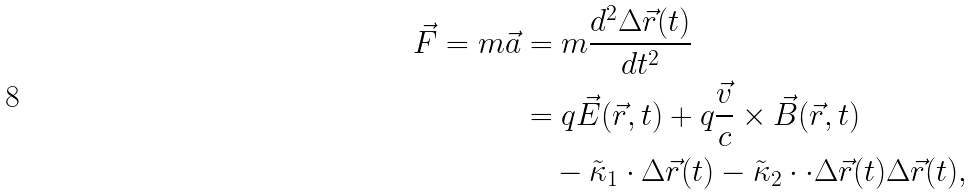<formula> <loc_0><loc_0><loc_500><loc_500>\vec { F } = m \vec { a } & = m \frac { d ^ { 2 } \Delta \vec { r } ( t ) } { d t ^ { 2 } } \\ & = q \vec { E } ( \vec { r } , t ) + q \frac { \vec { v } } { c } \times \vec { B } ( \vec { r } , t ) \\ & \quad - \tilde { \kappa } _ { 1 } \cdot \Delta \vec { r } ( t ) - \tilde { \kappa } _ { 2 } \cdot \cdot \Delta \vec { r } ( t ) \Delta \vec { r } ( t ) ,</formula> 